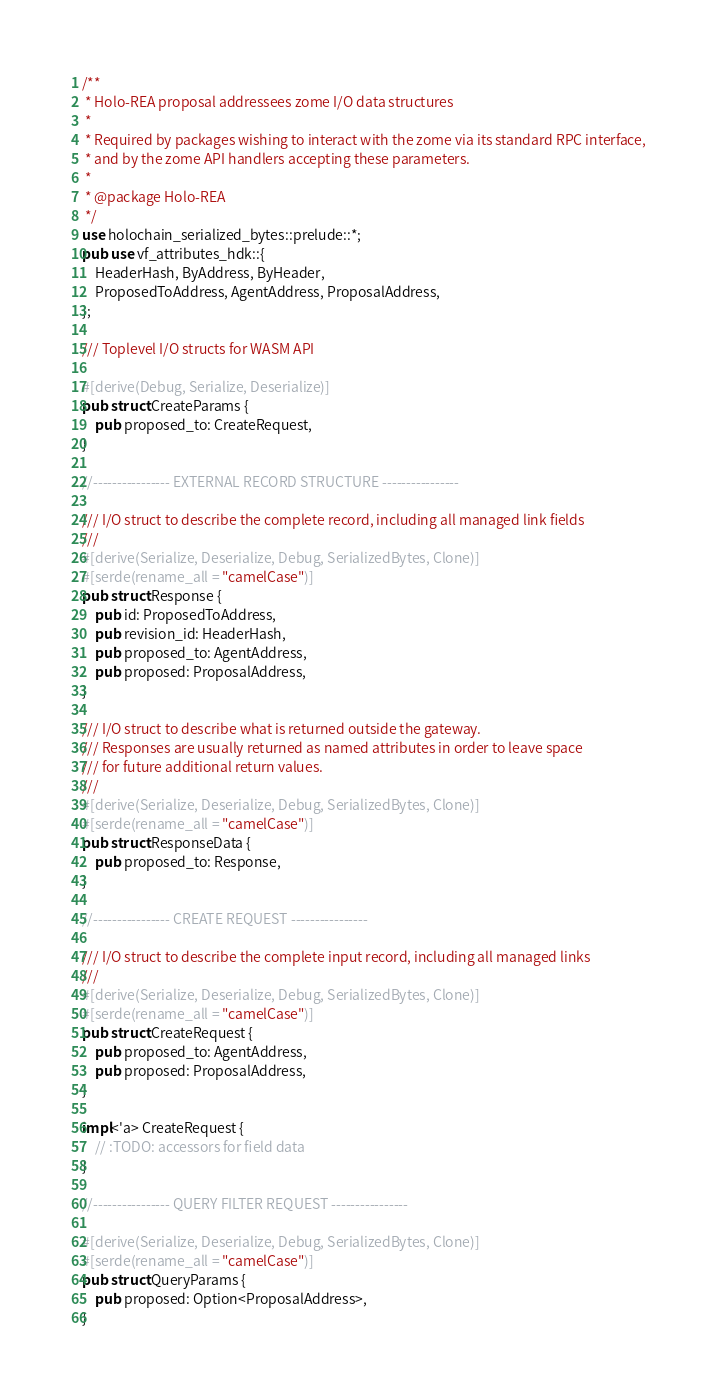<code> <loc_0><loc_0><loc_500><loc_500><_Rust_>/**
 * Holo-REA proposal addressees zome I/O data structures
 *
 * Required by packages wishing to interact with the zome via its standard RPC interface,
 * and by the zome API handlers accepting these parameters.
 *
 * @package Holo-REA
 */
use holochain_serialized_bytes::prelude::*;
pub use vf_attributes_hdk::{
    HeaderHash, ByAddress, ByHeader,
    ProposedToAddress, AgentAddress, ProposalAddress,
};

/// Toplevel I/O structs for WASM API

#[derive(Debug, Serialize, Deserialize)]
pub struct CreateParams {
    pub proposed_to: CreateRequest,
}

//---------------- EXTERNAL RECORD STRUCTURE ----------------

/// I/O struct to describe the complete record, including all managed link fields
///
#[derive(Serialize, Deserialize, Debug, SerializedBytes, Clone)]
#[serde(rename_all = "camelCase")]
pub struct Response {
    pub id: ProposedToAddress,
    pub revision_id: HeaderHash,
    pub proposed_to: AgentAddress,
    pub proposed: ProposalAddress,
}

/// I/O struct to describe what is returned outside the gateway.
/// Responses are usually returned as named attributes in order to leave space
/// for future additional return values.
///
#[derive(Serialize, Deserialize, Debug, SerializedBytes, Clone)]
#[serde(rename_all = "camelCase")]
pub struct ResponseData {
    pub proposed_to: Response,
}

//---------------- CREATE REQUEST ----------------

/// I/O struct to describe the complete input record, including all managed links
///
#[derive(Serialize, Deserialize, Debug, SerializedBytes, Clone)]
#[serde(rename_all = "camelCase")]
pub struct CreateRequest {
    pub proposed_to: AgentAddress,
    pub proposed: ProposalAddress,
}

impl<'a> CreateRequest {
    // :TODO: accessors for field data
}

//---------------- QUERY FILTER REQUEST ----------------

#[derive(Serialize, Deserialize, Debug, SerializedBytes, Clone)]
#[serde(rename_all = "camelCase")]
pub struct QueryParams {
    pub proposed: Option<ProposalAddress>,
}
</code> 